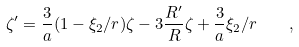<formula> <loc_0><loc_0><loc_500><loc_500>\zeta ^ { \prime } = \frac { 3 } { a } ( 1 - \xi _ { 2 } / r ) \zeta - 3 \frac { R ^ { \prime } } { R } \zeta + \frac { 3 } { a } \xi _ { 2 } / r \quad ,</formula> 